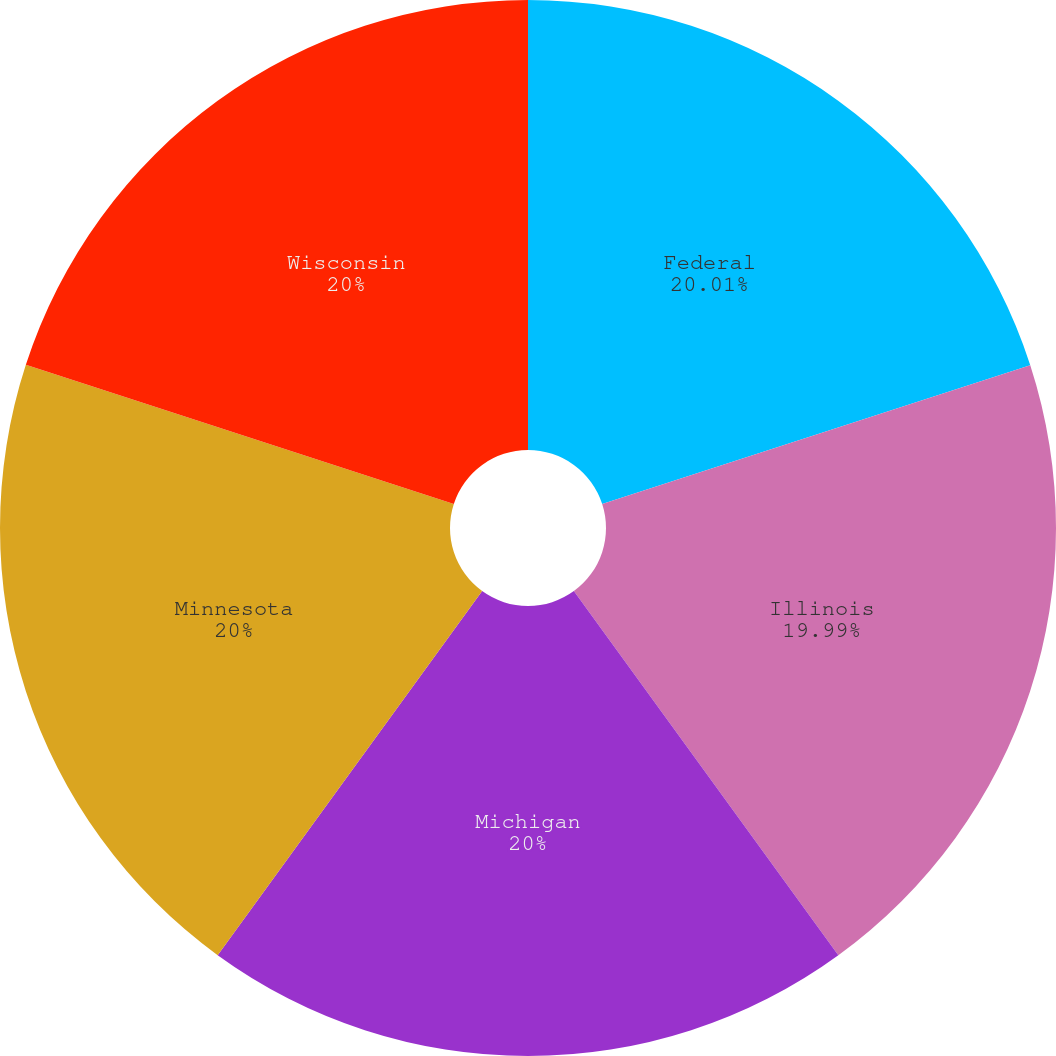<chart> <loc_0><loc_0><loc_500><loc_500><pie_chart><fcel>Federal<fcel>Illinois<fcel>Michigan<fcel>Minnesota<fcel>Wisconsin<nl><fcel>20.01%<fcel>19.99%<fcel>20.0%<fcel>20.0%<fcel>20.0%<nl></chart> 